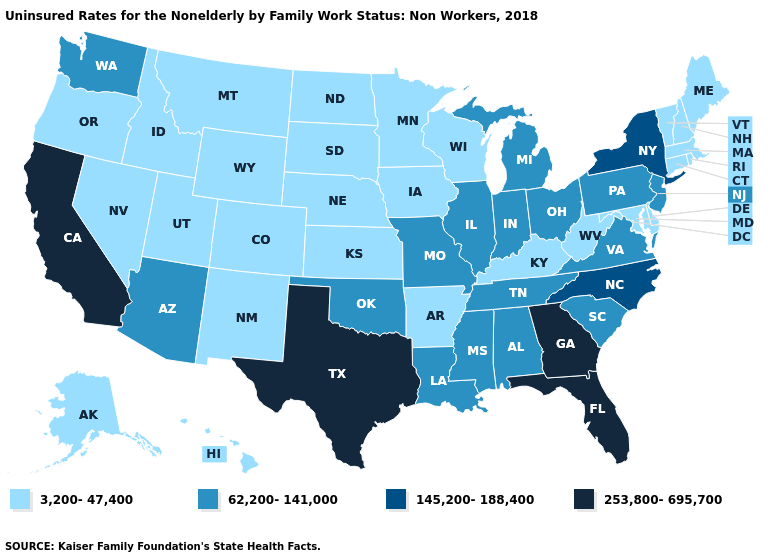What is the highest value in the USA?
Be succinct. 253,800-695,700. Name the states that have a value in the range 253,800-695,700?
Write a very short answer. California, Florida, Georgia, Texas. What is the highest value in states that border Rhode Island?
Keep it brief. 3,200-47,400. Name the states that have a value in the range 3,200-47,400?
Keep it brief. Alaska, Arkansas, Colorado, Connecticut, Delaware, Hawaii, Idaho, Iowa, Kansas, Kentucky, Maine, Maryland, Massachusetts, Minnesota, Montana, Nebraska, Nevada, New Hampshire, New Mexico, North Dakota, Oregon, Rhode Island, South Dakota, Utah, Vermont, West Virginia, Wisconsin, Wyoming. Does Maine have the lowest value in the Northeast?
Give a very brief answer. Yes. Name the states that have a value in the range 145,200-188,400?
Write a very short answer. New York, North Carolina. How many symbols are there in the legend?
Concise answer only. 4. Does Oklahoma have the lowest value in the USA?
Short answer required. No. Does Louisiana have a higher value than Maryland?
Answer briefly. Yes. What is the highest value in the USA?
Give a very brief answer. 253,800-695,700. Name the states that have a value in the range 253,800-695,700?
Quick response, please. California, Florida, Georgia, Texas. What is the value of Georgia?
Answer briefly. 253,800-695,700. Does Massachusetts have a lower value than Indiana?
Keep it brief. Yes. What is the value of Alabama?
Give a very brief answer. 62,200-141,000. What is the highest value in states that border Maryland?
Quick response, please. 62,200-141,000. 